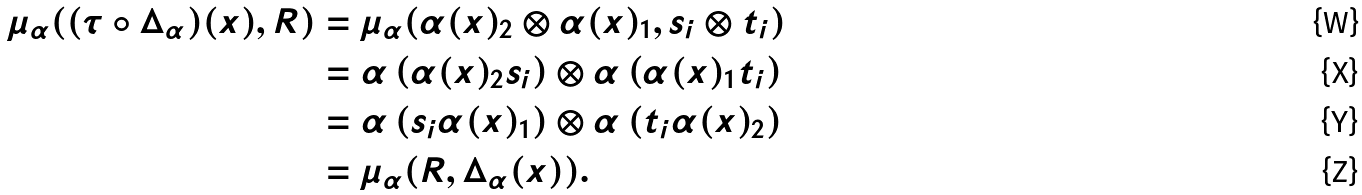Convert formula to latex. <formula><loc_0><loc_0><loc_500><loc_500>\mu _ { \alpha } ( ( \tau \circ \Delta _ { \alpha } ) ( x ) , R ) & = \mu _ { \alpha } ( \alpha ( x ) _ { 2 } \otimes \alpha ( x ) _ { 1 } , s _ { i } \otimes t _ { i } ) \\ & = \alpha \left ( \alpha ( x ) _ { 2 } s _ { i } \right ) \otimes \alpha \left ( \alpha ( x ) _ { 1 } t _ { i } \right ) \\ & = \alpha \left ( s _ { i } \alpha ( x ) _ { 1 } \right ) \otimes \alpha \left ( t _ { i } \alpha ( x ) _ { 2 } \right ) \\ & = \mu _ { \alpha } ( R , \Delta _ { \alpha } ( x ) ) .</formula> 